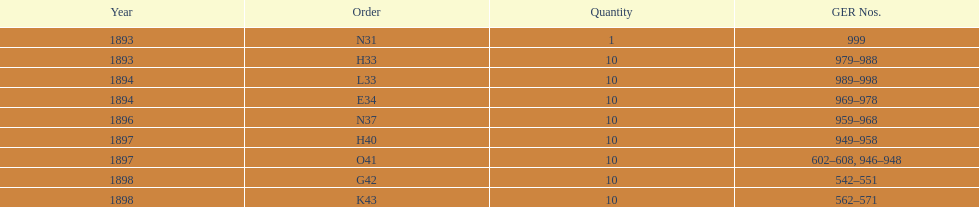Which year had the least ger numbers? 1893. 